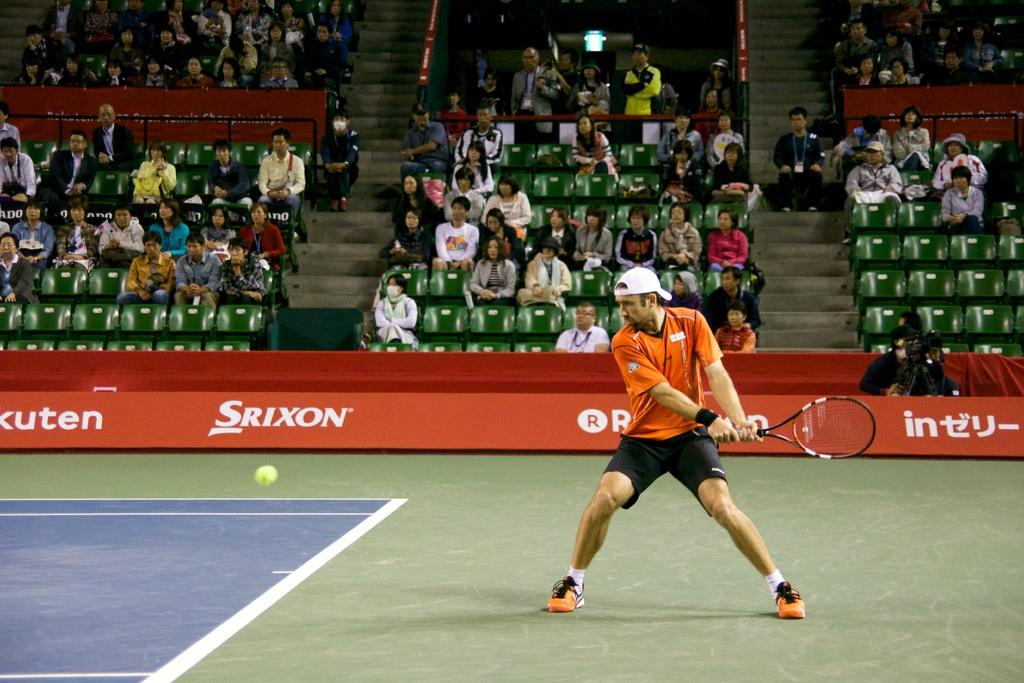<image>
Share a concise interpretation of the image provided. A tennis court with an advertisement for Srixon 